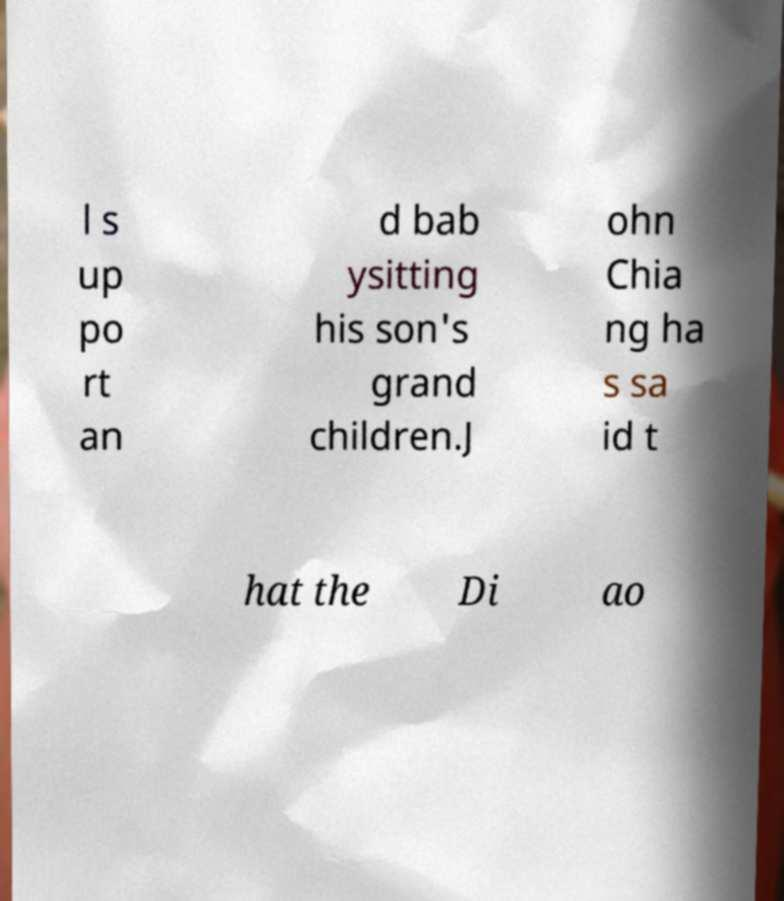Can you read and provide the text displayed in the image?This photo seems to have some interesting text. Can you extract and type it out for me? l s up po rt an d bab ysitting his son's grand children.J ohn Chia ng ha s sa id t hat the Di ao 